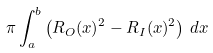<formula> <loc_0><loc_0><loc_500><loc_500>\pi \int _ { a } ^ { b } \left ( R _ { O } ( x ) ^ { 2 } - R _ { I } ( x ) ^ { 2 } \right ) \, d x</formula> 